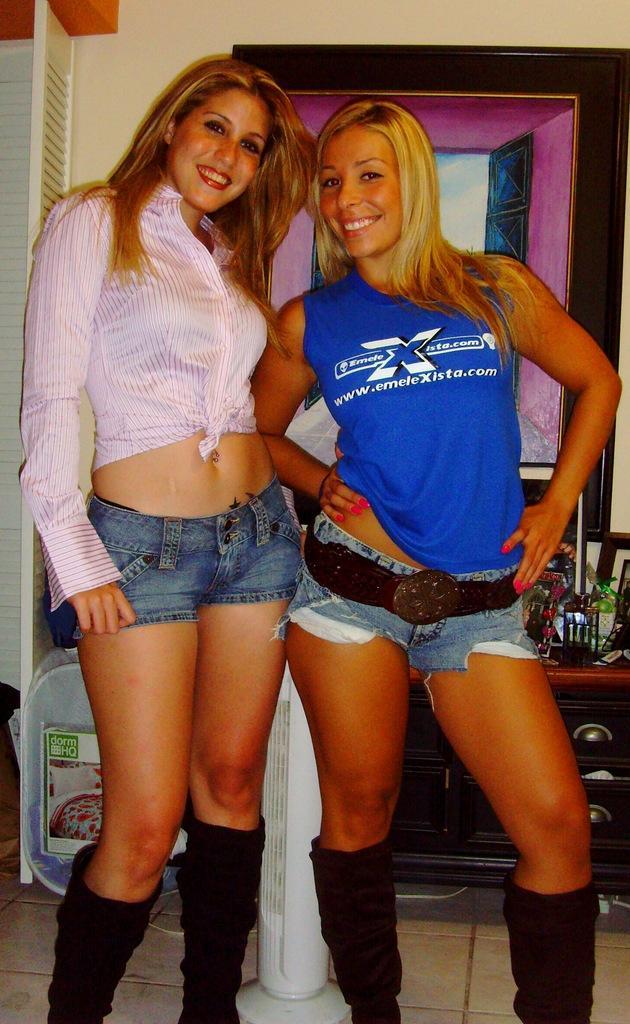Can you describe this image briefly? In this picture I can see couple of women standing and I can see mirror in the back and couple of photo frames on the table in the back and I can see a table fan and a cloth bag on the side. 